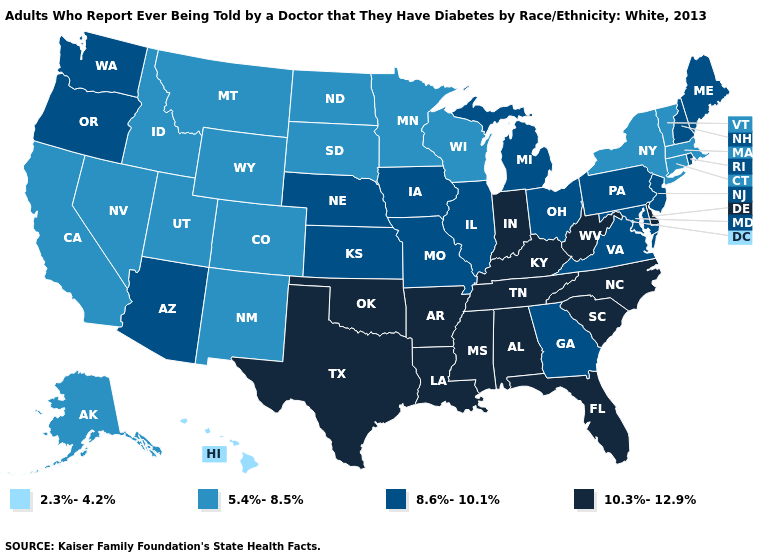Among the states that border California , which have the highest value?
Answer briefly. Arizona, Oregon. What is the value of Pennsylvania?
Keep it brief. 8.6%-10.1%. Which states have the highest value in the USA?
Keep it brief. Alabama, Arkansas, Delaware, Florida, Indiana, Kentucky, Louisiana, Mississippi, North Carolina, Oklahoma, South Carolina, Tennessee, Texas, West Virginia. Does Ohio have a lower value than Florida?
Answer briefly. Yes. Does Hawaii have the lowest value in the USA?
Give a very brief answer. Yes. Name the states that have a value in the range 10.3%-12.9%?
Concise answer only. Alabama, Arkansas, Delaware, Florida, Indiana, Kentucky, Louisiana, Mississippi, North Carolina, Oklahoma, South Carolina, Tennessee, Texas, West Virginia. What is the lowest value in the South?
Concise answer only. 8.6%-10.1%. Name the states that have a value in the range 10.3%-12.9%?
Answer briefly. Alabama, Arkansas, Delaware, Florida, Indiana, Kentucky, Louisiana, Mississippi, North Carolina, Oklahoma, South Carolina, Tennessee, Texas, West Virginia. Does Rhode Island have a higher value than New York?
Write a very short answer. Yes. Does Oklahoma have the lowest value in the USA?
Keep it brief. No. Does Virginia have the highest value in the South?
Short answer required. No. Name the states that have a value in the range 5.4%-8.5%?
Give a very brief answer. Alaska, California, Colorado, Connecticut, Idaho, Massachusetts, Minnesota, Montana, Nevada, New Mexico, New York, North Dakota, South Dakota, Utah, Vermont, Wisconsin, Wyoming. Does Kentucky have a lower value than Nevada?
Keep it brief. No. Which states have the lowest value in the MidWest?
Keep it brief. Minnesota, North Dakota, South Dakota, Wisconsin. Name the states that have a value in the range 2.3%-4.2%?
Short answer required. Hawaii. 